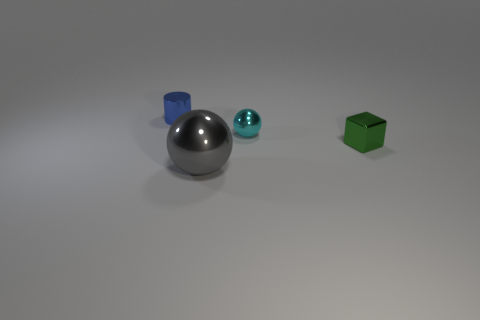Add 4 blue metal things. How many objects exist? 8 Subtract all cubes. How many objects are left? 3 Add 1 green shiny things. How many green shiny things are left? 2 Add 3 big purple metal cylinders. How many big purple metal cylinders exist? 3 Subtract 0 yellow cylinders. How many objects are left? 4 Subtract all tiny blue metallic things. Subtract all gray objects. How many objects are left? 2 